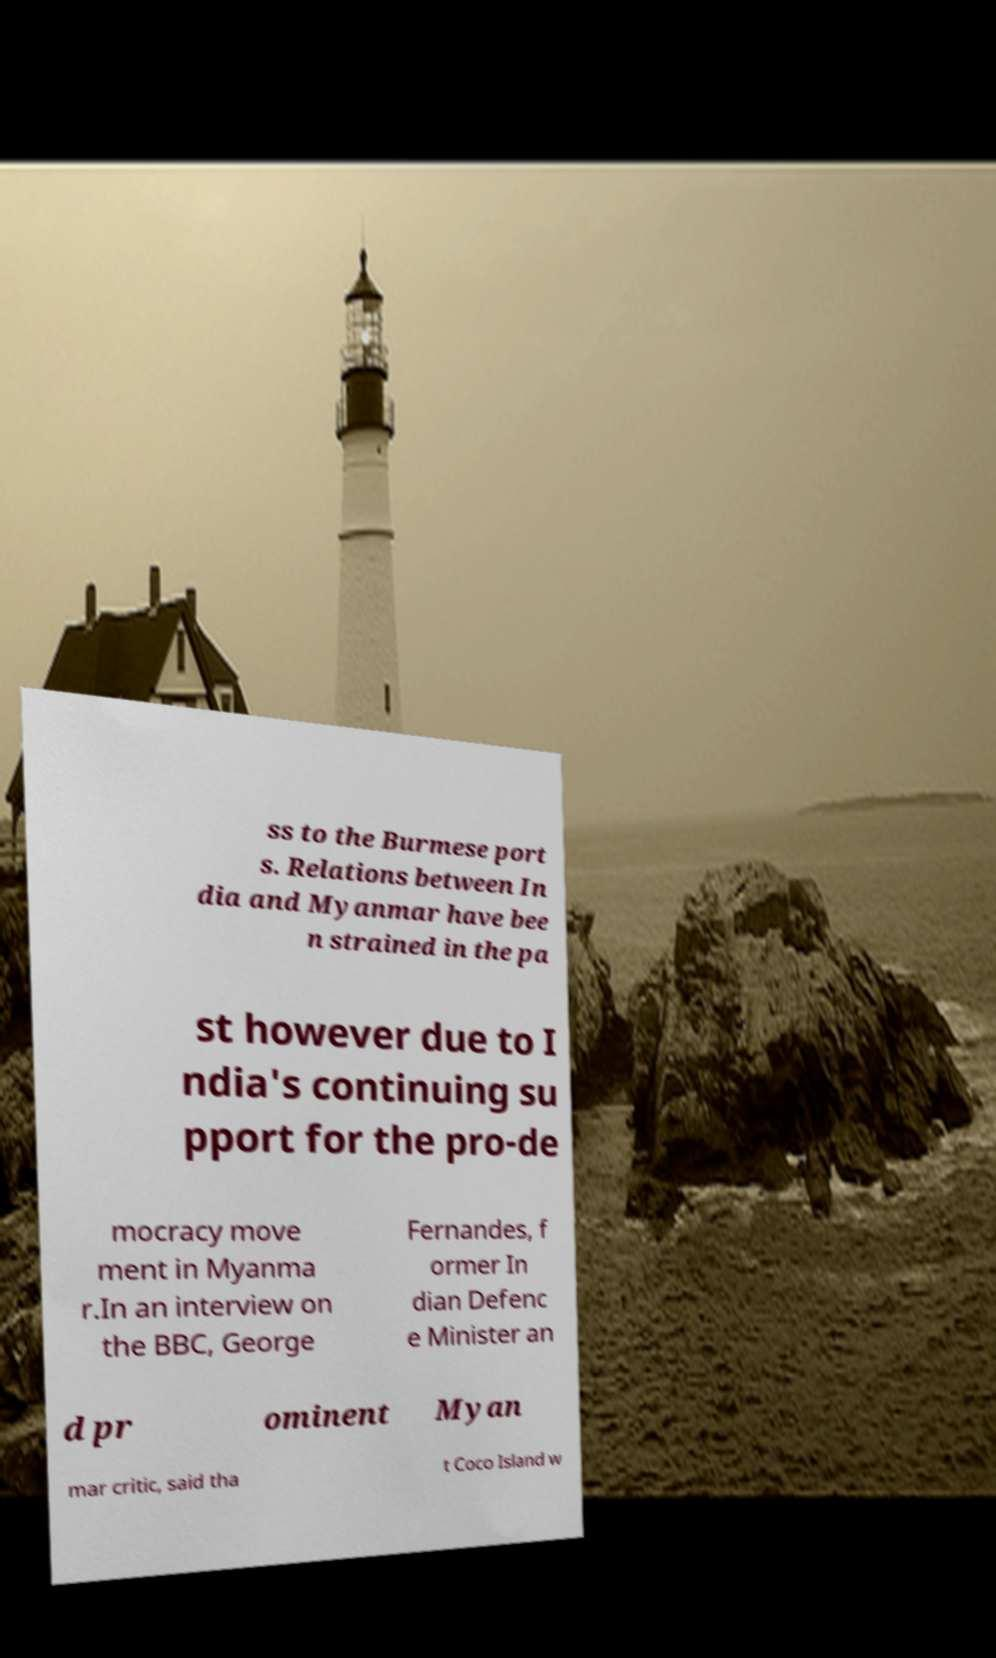There's text embedded in this image that I need extracted. Can you transcribe it verbatim? ss to the Burmese port s. Relations between In dia and Myanmar have bee n strained in the pa st however due to I ndia's continuing su pport for the pro-de mocracy move ment in Myanma r.In an interview on the BBC, George Fernandes, f ormer In dian Defenc e Minister an d pr ominent Myan mar critic, said tha t Coco Island w 